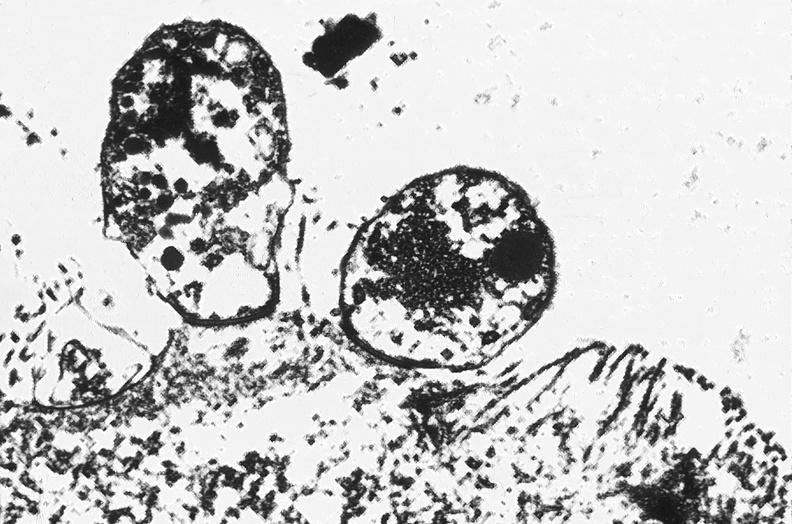what does this image show?
Answer the question using a single word or phrase. Colon 